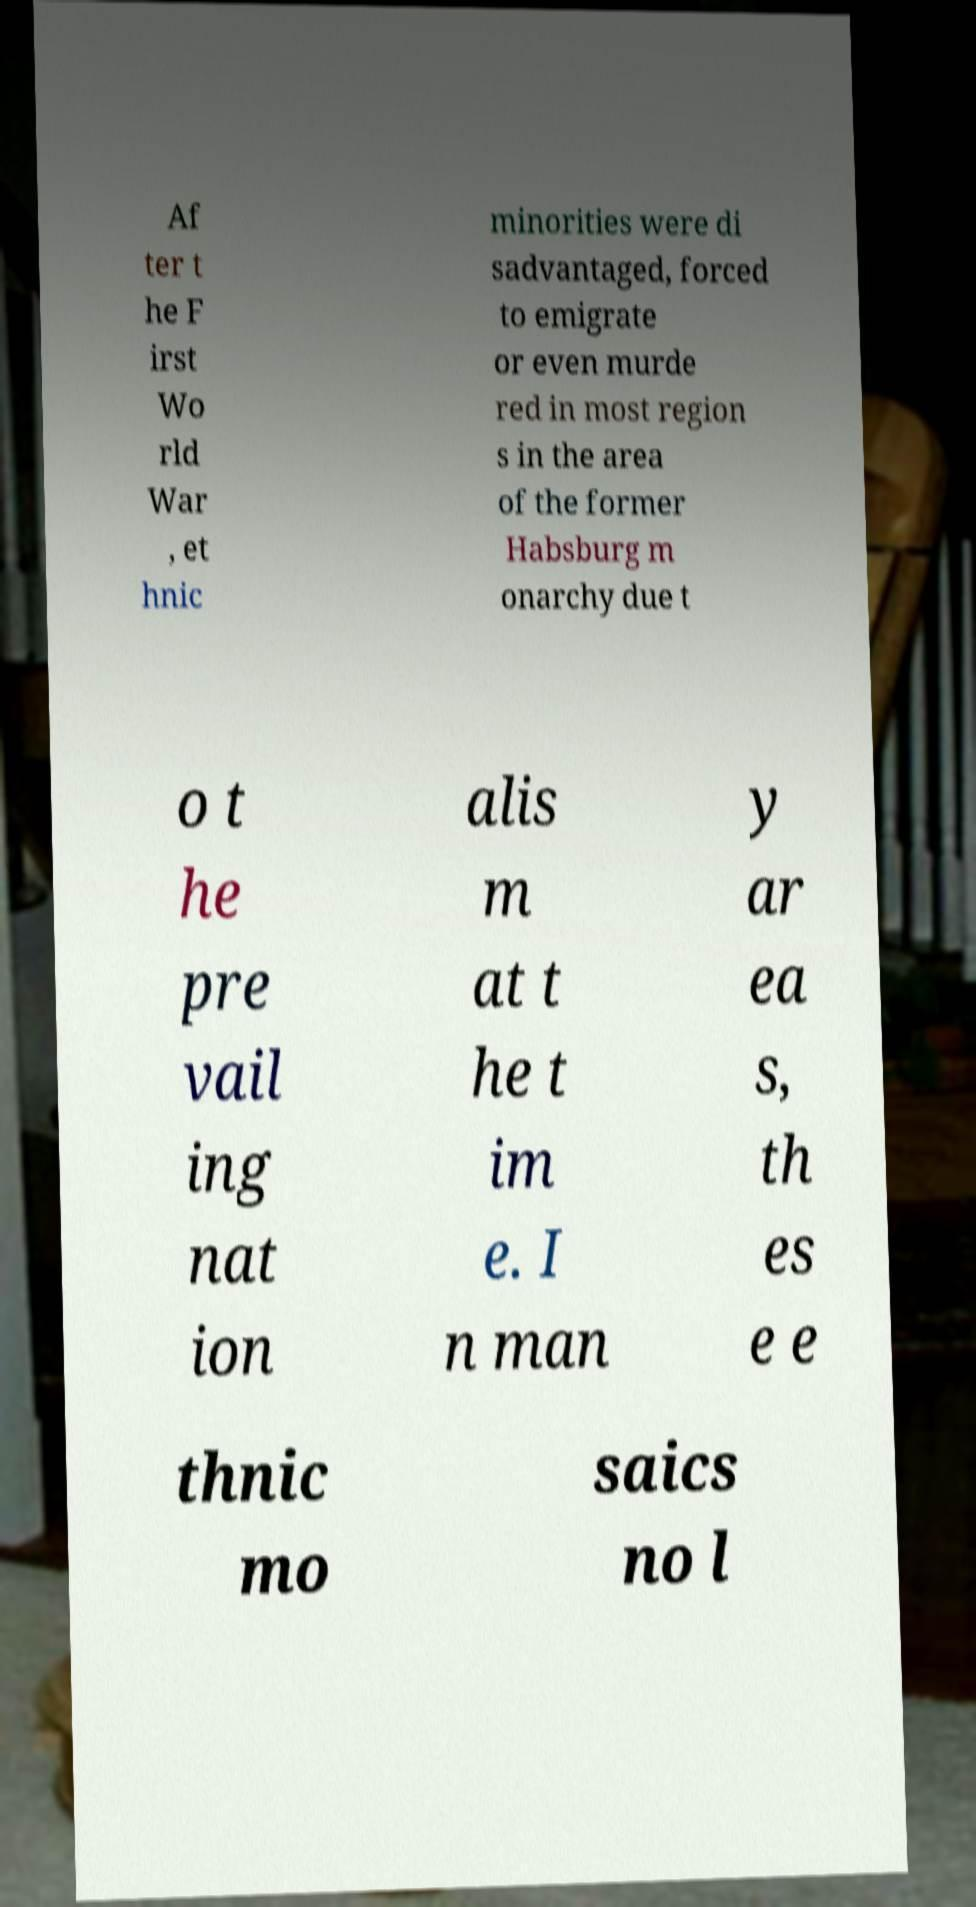I need the written content from this picture converted into text. Can you do that? Af ter t he F irst Wo rld War , et hnic minorities were di sadvantaged, forced to emigrate or even murde red in most region s in the area of the former Habsburg m onarchy due t o t he pre vail ing nat ion alis m at t he t im e. I n man y ar ea s, th es e e thnic mo saics no l 